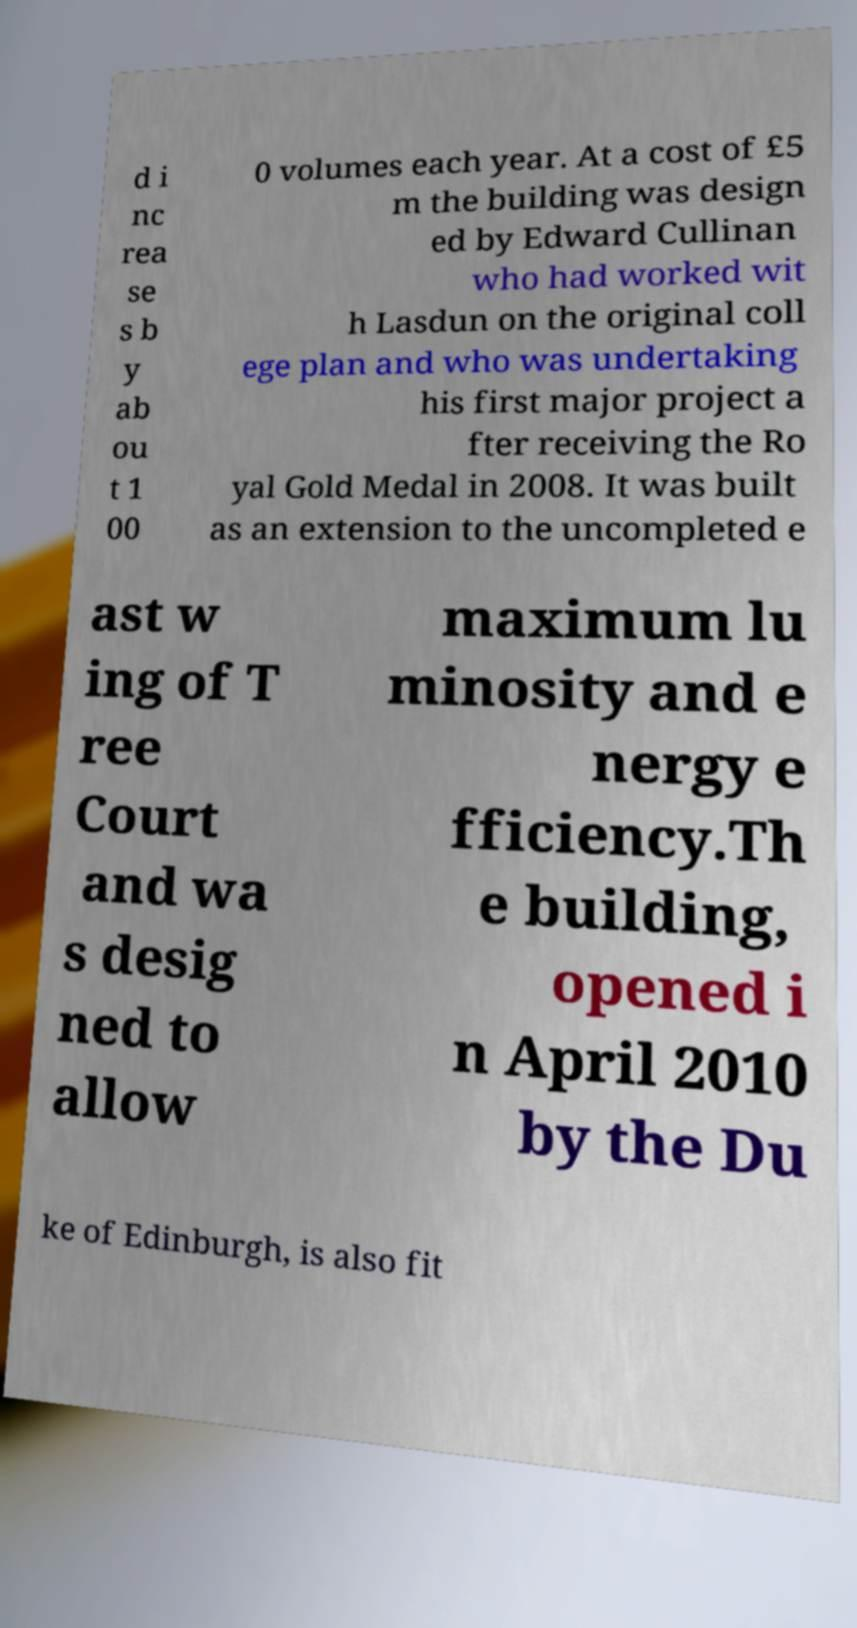What messages or text are displayed in this image? I need them in a readable, typed format. d i nc rea se s b y ab ou t 1 00 0 volumes each year. At a cost of £5 m the building was design ed by Edward Cullinan who had worked wit h Lasdun on the original coll ege plan and who was undertaking his first major project a fter receiving the Ro yal Gold Medal in 2008. It was built as an extension to the uncompleted e ast w ing of T ree Court and wa s desig ned to allow maximum lu minosity and e nergy e fficiency.Th e building, opened i n April 2010 by the Du ke of Edinburgh, is also fit 